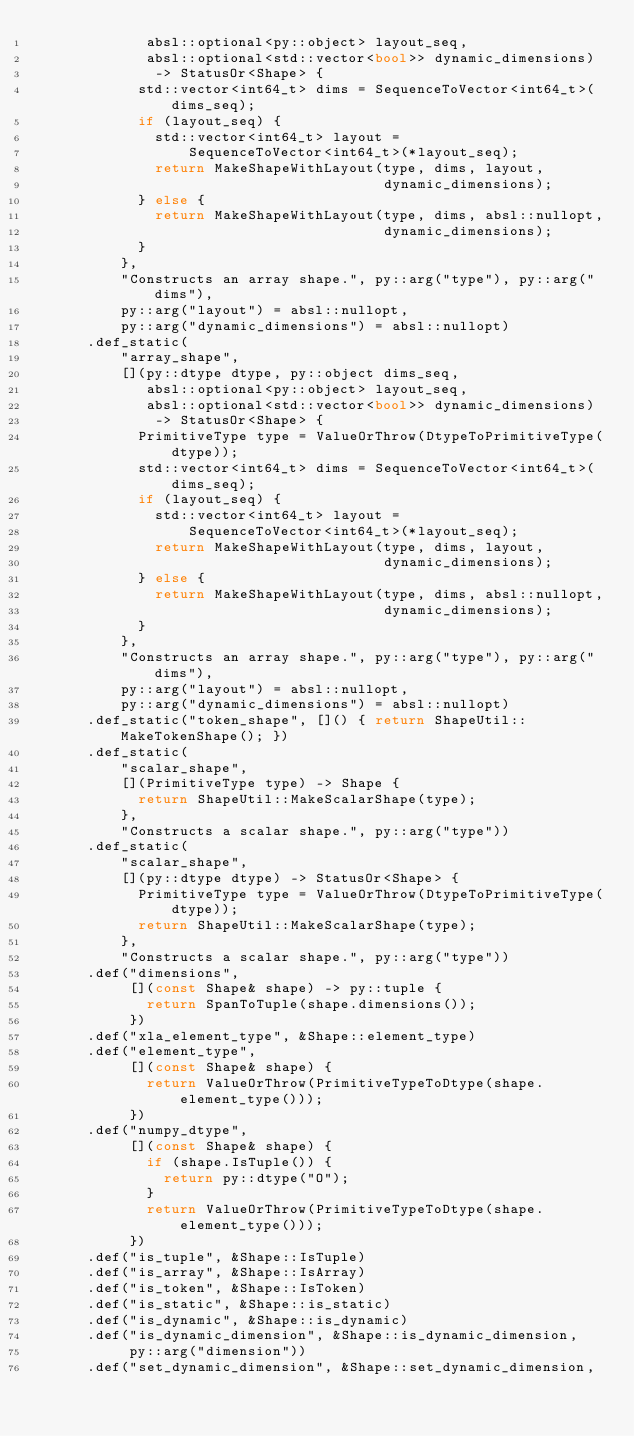Convert code to text. <code><loc_0><loc_0><loc_500><loc_500><_C++_>             absl::optional<py::object> layout_seq,
             absl::optional<std::vector<bool>> dynamic_dimensions)
              -> StatusOr<Shape> {
            std::vector<int64_t> dims = SequenceToVector<int64_t>(dims_seq);
            if (layout_seq) {
              std::vector<int64_t> layout =
                  SequenceToVector<int64_t>(*layout_seq);
              return MakeShapeWithLayout(type, dims, layout,
                                         dynamic_dimensions);
            } else {
              return MakeShapeWithLayout(type, dims, absl::nullopt,
                                         dynamic_dimensions);
            }
          },
          "Constructs an array shape.", py::arg("type"), py::arg("dims"),
          py::arg("layout") = absl::nullopt,
          py::arg("dynamic_dimensions") = absl::nullopt)
      .def_static(
          "array_shape",
          [](py::dtype dtype, py::object dims_seq,
             absl::optional<py::object> layout_seq,
             absl::optional<std::vector<bool>> dynamic_dimensions)
              -> StatusOr<Shape> {
            PrimitiveType type = ValueOrThrow(DtypeToPrimitiveType(dtype));
            std::vector<int64_t> dims = SequenceToVector<int64_t>(dims_seq);
            if (layout_seq) {
              std::vector<int64_t> layout =
                  SequenceToVector<int64_t>(*layout_seq);
              return MakeShapeWithLayout(type, dims, layout,
                                         dynamic_dimensions);
            } else {
              return MakeShapeWithLayout(type, dims, absl::nullopt,
                                         dynamic_dimensions);
            }
          },
          "Constructs an array shape.", py::arg("type"), py::arg("dims"),
          py::arg("layout") = absl::nullopt,
          py::arg("dynamic_dimensions") = absl::nullopt)
      .def_static("token_shape", []() { return ShapeUtil::MakeTokenShape(); })
      .def_static(
          "scalar_shape",
          [](PrimitiveType type) -> Shape {
            return ShapeUtil::MakeScalarShape(type);
          },
          "Constructs a scalar shape.", py::arg("type"))
      .def_static(
          "scalar_shape",
          [](py::dtype dtype) -> StatusOr<Shape> {
            PrimitiveType type = ValueOrThrow(DtypeToPrimitiveType(dtype));
            return ShapeUtil::MakeScalarShape(type);
          },
          "Constructs a scalar shape.", py::arg("type"))
      .def("dimensions",
           [](const Shape& shape) -> py::tuple {
             return SpanToTuple(shape.dimensions());
           })
      .def("xla_element_type", &Shape::element_type)
      .def("element_type",
           [](const Shape& shape) {
             return ValueOrThrow(PrimitiveTypeToDtype(shape.element_type()));
           })
      .def("numpy_dtype",
           [](const Shape& shape) {
             if (shape.IsTuple()) {
               return py::dtype("O");
             }
             return ValueOrThrow(PrimitiveTypeToDtype(shape.element_type()));
           })
      .def("is_tuple", &Shape::IsTuple)
      .def("is_array", &Shape::IsArray)
      .def("is_token", &Shape::IsToken)
      .def("is_static", &Shape::is_static)
      .def("is_dynamic", &Shape::is_dynamic)
      .def("is_dynamic_dimension", &Shape::is_dynamic_dimension,
           py::arg("dimension"))
      .def("set_dynamic_dimension", &Shape::set_dynamic_dimension,</code> 